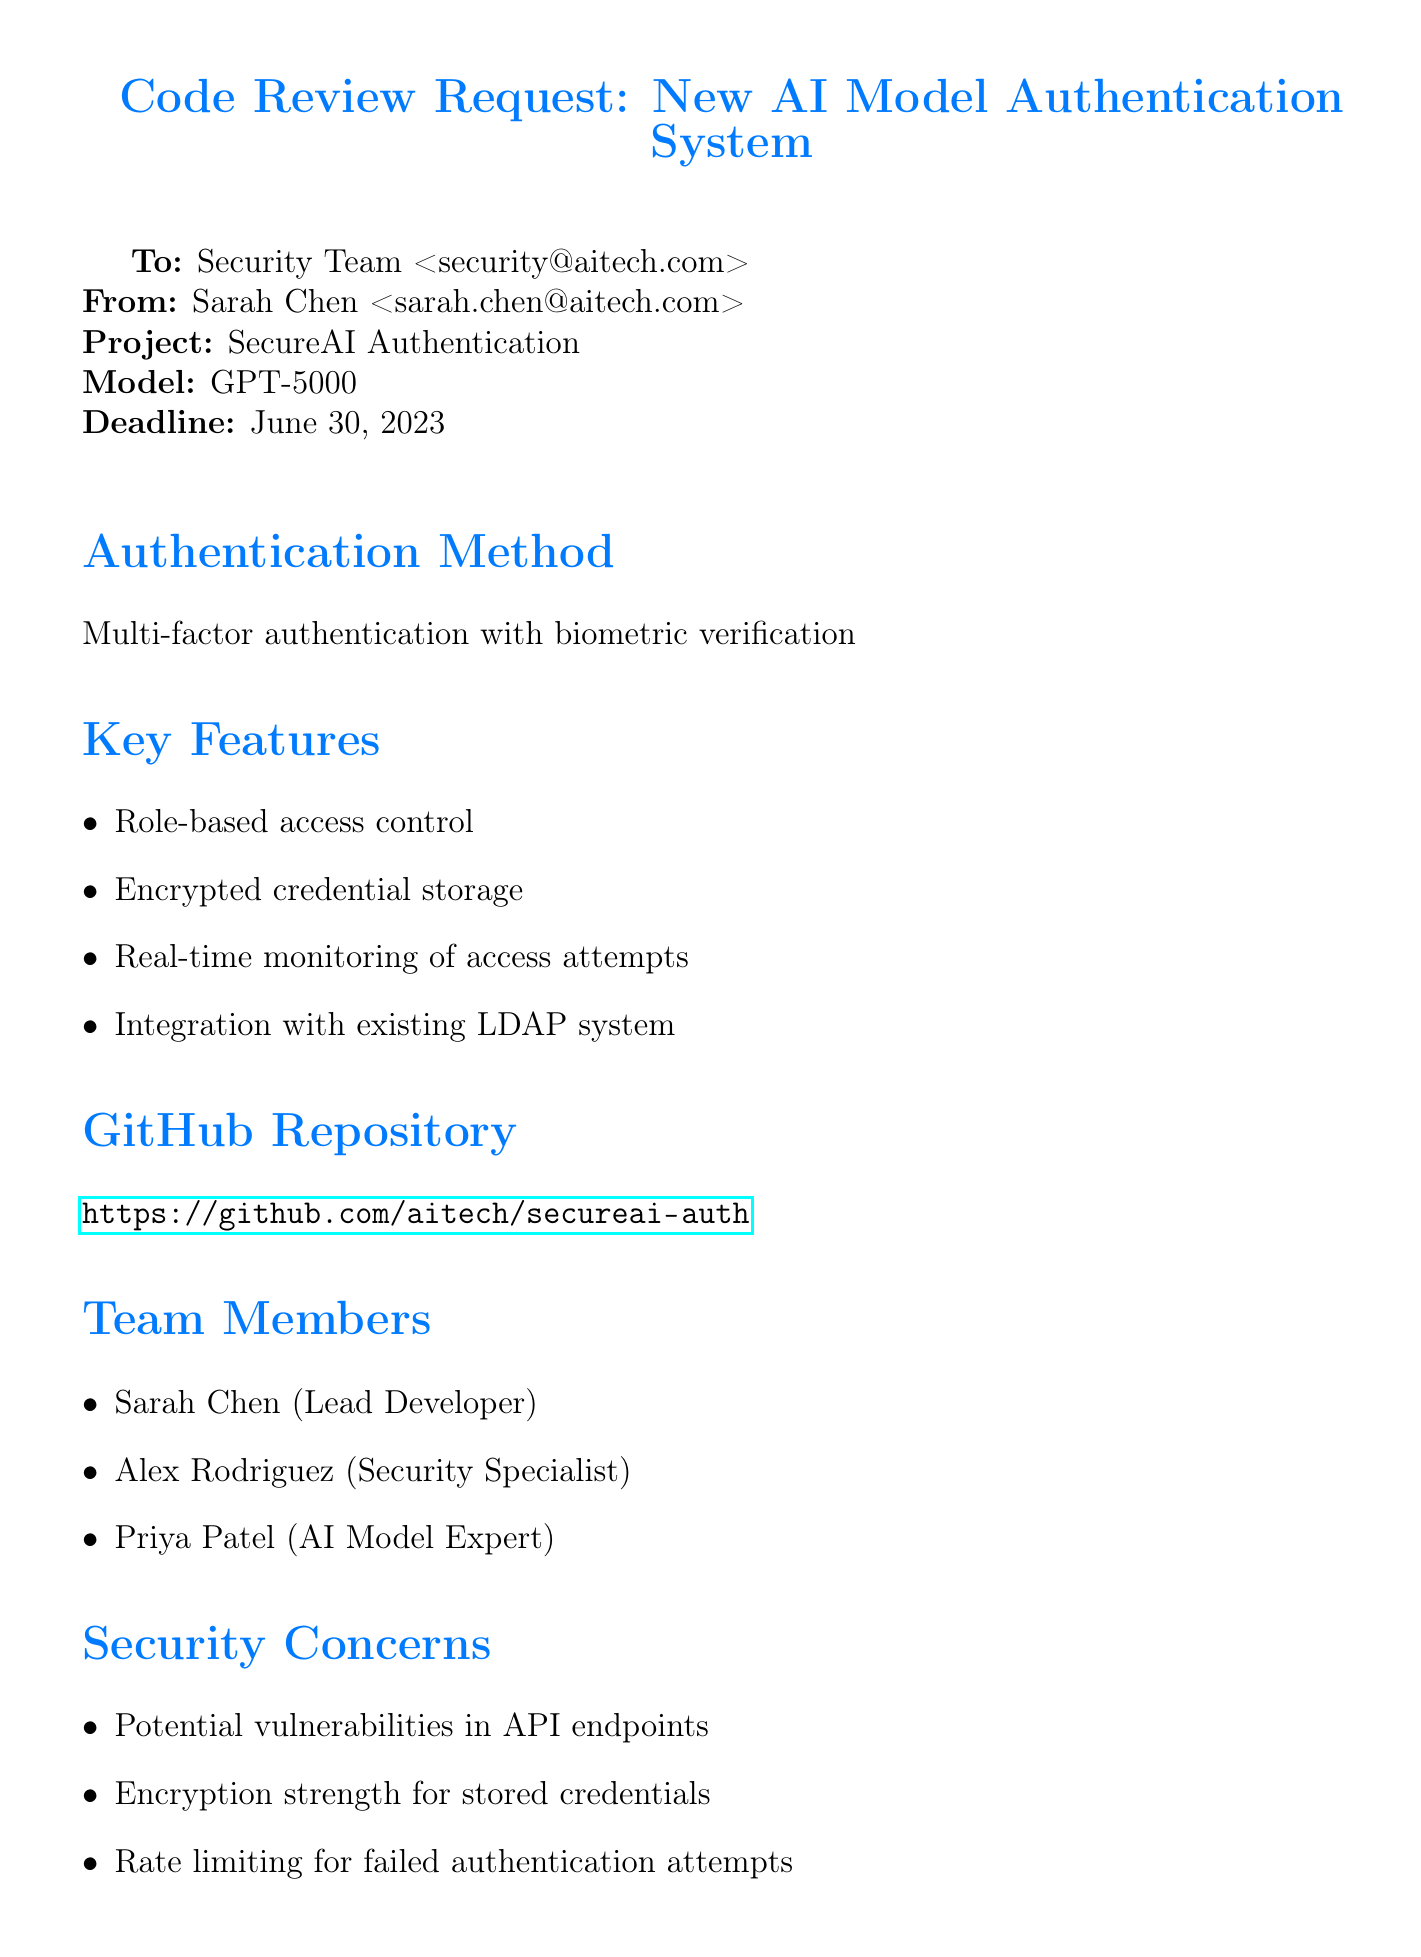What is the project name? The project name is mentioned in the document as "SecureAI Authentication."
Answer: SecureAI Authentication Who is the lead developer? The document lists the lead developer as "Sarah Chen."
Answer: Sarah Chen What is the authentication method used? The authentication method is outlined in the document as "Multi-factor authentication with biometric verification."
Answer: Multi-factor authentication with biometric verification What is the code review deadline? The deadline for the code review is specified as "June 30, 2023."
Answer: June 30, 2023 Which compliance requirements are mentioned? The document lists compliance requirements including GDPR, ISO 27001, and NIST Cybersecurity Framework.
Answer: GDPR, ISO 27001, NIST Cybersecurity Framework What are the key features highlighted in the document? The key features of the system include role-based access control, encrypted credential storage, real-time monitoring of access attempts, and integration with existing LDAP system.
Answer: Role-based access control, encrypted credential storage, real-time monitoring of access attempts, integration with existing LDAP system What is the testing environment for this project? The testing environment is specified as "AWS EC2 instance with Docker containers."
Answer: AWS EC2 instance with Docker containers Which security concerns are identified? The security concerns mentioned in the document include potential vulnerabilities in API endpoints, encryption strength for stored credentials, and rate limiting for failed authentication attempts.
Answer: Potential vulnerabilities in API endpoints, encryption strength for stored credentials, rate limiting for failed authentication attempts 